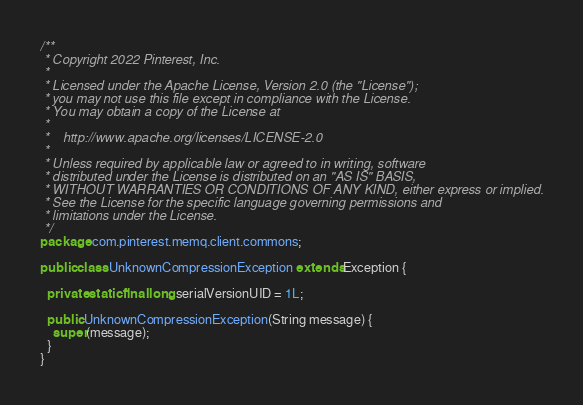Convert code to text. <code><loc_0><loc_0><loc_500><loc_500><_Java_>/**
 * Copyright 2022 Pinterest, Inc.
 * 
 * Licensed under the Apache License, Version 2.0 (the "License");
 * you may not use this file except in compliance with the License.
 * You may obtain a copy of the License at
 * 
 *    http://www.apache.org/licenses/LICENSE-2.0
 * 
 * Unless required by applicable law or agreed to in writing, software
 * distributed under the License is distributed on an "AS IS" BASIS,
 * WITHOUT WARRANTIES OR CONDITIONS OF ANY KIND, either express or implied.
 * See the License for the specific language governing permissions and
 * limitations under the License.
 */
package com.pinterest.memq.client.commons;

public class UnknownCompressionException extends Exception {

  private static final long serialVersionUID = 1L;

  public UnknownCompressionException(String message) {
    super(message);
  }
}</code> 